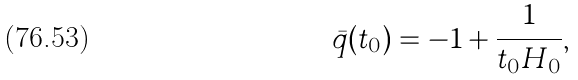<formula> <loc_0><loc_0><loc_500><loc_500>\bar { q } ( t _ { 0 } ) = - 1 + \frac { 1 } { t _ { 0 } H _ { 0 } } ,</formula> 